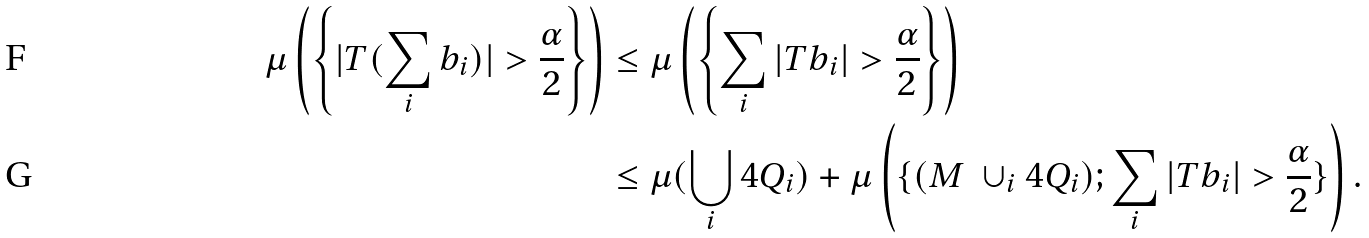Convert formula to latex. <formula><loc_0><loc_0><loc_500><loc_500>\mu \left ( \left \{ | T ( \sum _ { i } b _ { i } ) | > \frac { \alpha } { 2 } \right \} \right ) & \leq \mu \left ( \left \{ \sum _ { i } | T b _ { i } | > \frac { \alpha } { 2 } \right \} \right ) \\ & \leq \mu ( \bigcup _ { i } 4 Q _ { i } ) + \mu \left ( \{ ( M \ \cup _ { i } 4 Q _ { i } ) ; \sum _ { i } | T b _ { i } | > \frac { \alpha } { 2 } \} \right ) .</formula> 